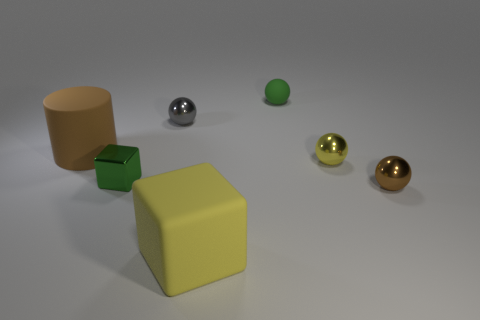Subtract all cylinders. How many objects are left? 6 Subtract 1 blocks. How many blocks are left? 1 Subtract all cyan balls. Subtract all cyan cylinders. How many balls are left? 4 Subtract all red cubes. How many gray spheres are left? 1 Subtract all big rubber cubes. Subtract all tiny green matte balls. How many objects are left? 5 Add 2 gray shiny balls. How many gray shiny balls are left? 3 Add 5 tiny gray rubber cylinders. How many tiny gray rubber cylinders exist? 5 Add 2 matte spheres. How many objects exist? 9 Subtract all yellow balls. How many balls are left? 3 Subtract all small green rubber spheres. How many spheres are left? 3 